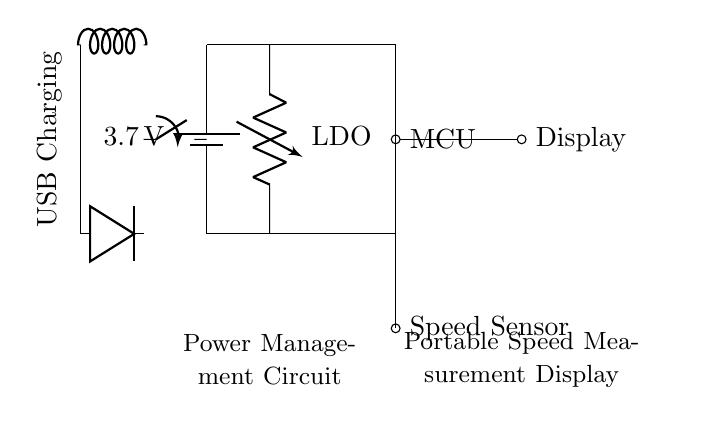What is the power source voltage in this circuit? The power source in the circuit is a battery labeled with a voltage of 3.7 volts, which is indicated next to the battery symbol. This is the initial voltage supplied to the entire circuit.
Answer: 3.7 volts What type of voltage regulator is in use? The circuit diagram specifies an LDO (Low Drop-Out) regulator, identified by the label next to the voltage regulator symbol. This type of regulator is designed for efficient voltage regulation with minimal voltage drop.
Answer: LDO How many main components are powered by the circuit? The circuit diagram shows three main components being powered: the microcontroller, the display, and the speed sensor, all indicated by their respective labels within the diagram.
Answer: Three What is the purpose of the switch in the circuit? The switch connects and disconnects the power from the battery to the rest of the circuit, allowing the user to control the operation of the circuit. This is established by observing the switch's placement in relation to the battery and other components.
Answer: Power control Which component is responsible for detecting speed? The speed sensor is responsible for detecting speed, as indicated clearly by its labeling in the circuit diagram. It is connected to the microcontroller and indicates its function as a measurement device.
Answer: Speed sensor How is the circuit charged? The circuit diagram includes a USB charging circuit represented by the inductor and diode symbols, along with a label that clearly states "USB Charging", which shows that the circuit can be recharged via USB.
Answer: USB charging What type of device is this circuit designed for? Based on the labels in the circuit diagram, this circuit is designed for a portable speed measurement display, which is typical of devices used in speed skating rinks and similar environments.
Answer: Portable speed measurement display 